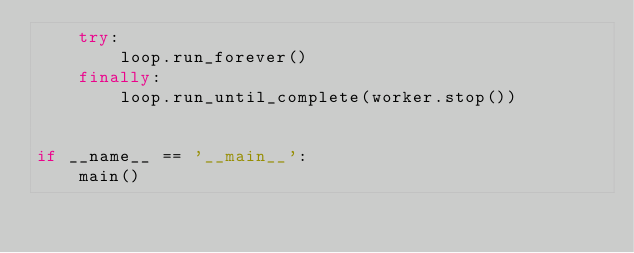<code> <loc_0><loc_0><loc_500><loc_500><_Python_>    try:
        loop.run_forever()
    finally:
        loop.run_until_complete(worker.stop())


if __name__ == '__main__':
    main()
</code> 